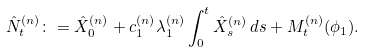Convert formula to latex. <formula><loc_0><loc_0><loc_500><loc_500>\hat { N } _ { t } ^ { ( n ) } \colon = \hat { X } _ { 0 } ^ { ( n ) } + c _ { 1 } ^ { ( n ) } \lambda _ { 1 } ^ { ( n ) } \int _ { 0 } ^ { t } \hat { X } _ { s } ^ { ( n ) } \, d s + M ^ { ( n ) } _ { t } ( \phi _ { 1 } ) .</formula> 